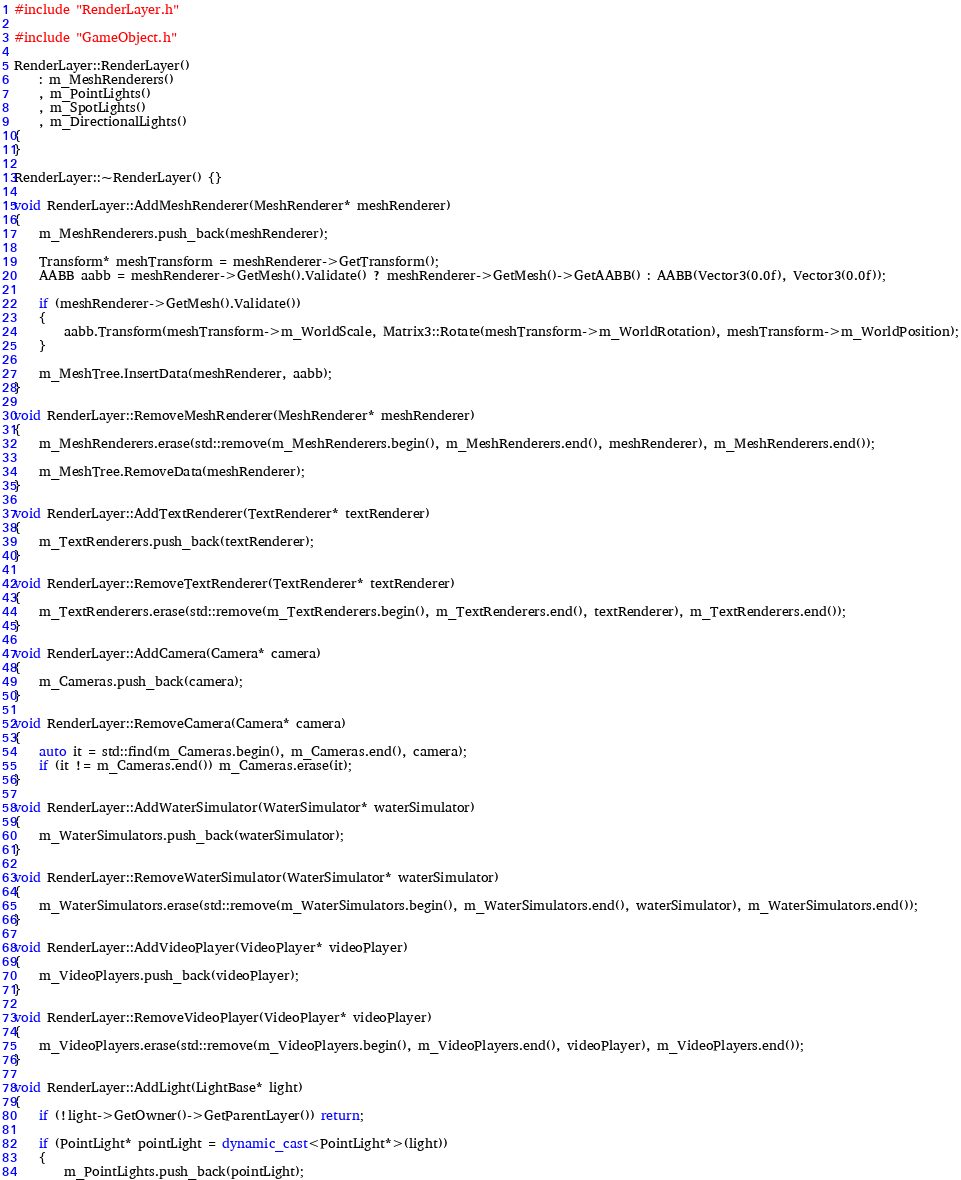Convert code to text. <code><loc_0><loc_0><loc_500><loc_500><_C++_>#include "RenderLayer.h"

#include "GameObject.h"

RenderLayer::RenderLayer()
    : m_MeshRenderers()
    , m_PointLights()
    , m_SpotLights()
    , m_DirectionalLights()
{
}

RenderLayer::~RenderLayer() {}

void RenderLayer::AddMeshRenderer(MeshRenderer* meshRenderer)
{
    m_MeshRenderers.push_back(meshRenderer);

    Transform* meshTransform = meshRenderer->GetTransform();
    AABB aabb = meshRenderer->GetMesh().Validate() ? meshRenderer->GetMesh()->GetAABB() : AABB(Vector3(0.0f), Vector3(0.0f));

    if (meshRenderer->GetMesh().Validate())
    {
        aabb.Transform(meshTransform->m_WorldScale, Matrix3::Rotate(meshTransform->m_WorldRotation), meshTransform->m_WorldPosition);
    }

    m_MeshTree.InsertData(meshRenderer, aabb);
}

void RenderLayer::RemoveMeshRenderer(MeshRenderer* meshRenderer)
{
    m_MeshRenderers.erase(std::remove(m_MeshRenderers.begin(), m_MeshRenderers.end(), meshRenderer), m_MeshRenderers.end());

    m_MeshTree.RemoveData(meshRenderer);
}

void RenderLayer::AddTextRenderer(TextRenderer* textRenderer)
{
    m_TextRenderers.push_back(textRenderer);
}

void RenderLayer::RemoveTextRenderer(TextRenderer* textRenderer)
{
    m_TextRenderers.erase(std::remove(m_TextRenderers.begin(), m_TextRenderers.end(), textRenderer), m_TextRenderers.end());
}

void RenderLayer::AddCamera(Camera* camera)
{
    m_Cameras.push_back(camera);
}

void RenderLayer::RemoveCamera(Camera* camera)
{
    auto it = std::find(m_Cameras.begin(), m_Cameras.end(), camera);
    if (it != m_Cameras.end()) m_Cameras.erase(it);
}

void RenderLayer::AddWaterSimulator(WaterSimulator* waterSimulator)
{
    m_WaterSimulators.push_back(waterSimulator);
}

void RenderLayer::RemoveWaterSimulator(WaterSimulator* waterSimulator)
{
    m_WaterSimulators.erase(std::remove(m_WaterSimulators.begin(), m_WaterSimulators.end(), waterSimulator), m_WaterSimulators.end());
}

void RenderLayer::AddVideoPlayer(VideoPlayer* videoPlayer)
{
    m_VideoPlayers.push_back(videoPlayer);
}

void RenderLayer::RemoveVideoPlayer(VideoPlayer* videoPlayer)
{
    m_VideoPlayers.erase(std::remove(m_VideoPlayers.begin(), m_VideoPlayers.end(), videoPlayer), m_VideoPlayers.end());
}

void RenderLayer::AddLight(LightBase* light)
{
    if (!light->GetOwner()->GetParentLayer()) return;

    if (PointLight* pointLight = dynamic_cast<PointLight*>(light))
    {
        m_PointLights.push_back(pointLight);
</code> 